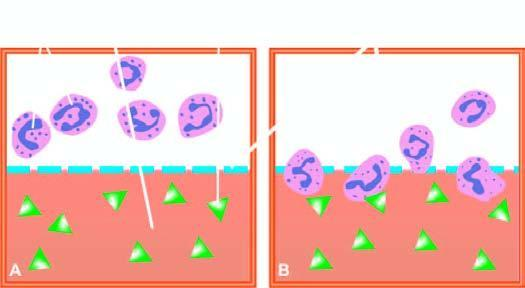does these end components of chromosome show migration of neutrophils towards chemotactic agent?
Answer the question using a single word or phrase. No 